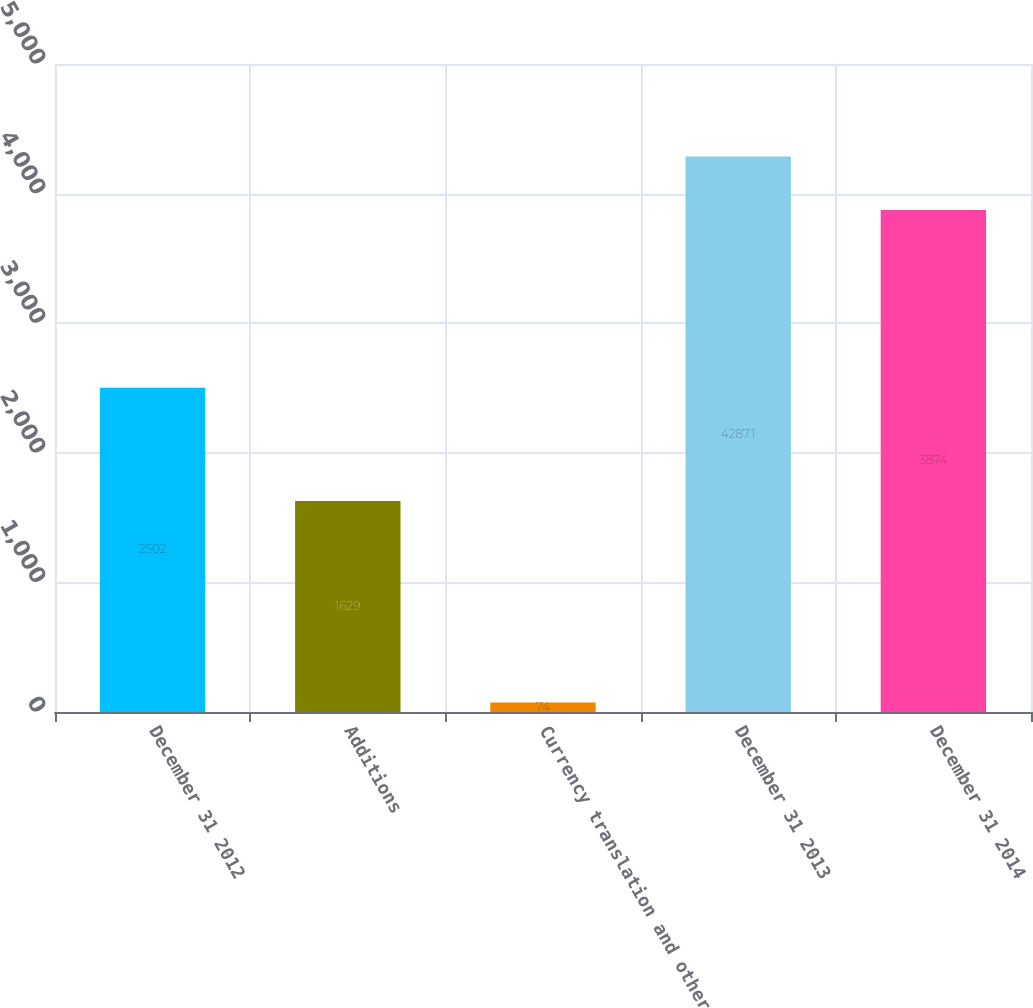Convert chart to OTSL. <chart><loc_0><loc_0><loc_500><loc_500><bar_chart><fcel>December 31 2012<fcel>Additions<fcel>Currency translation and other<fcel>December 31 2013<fcel>December 31 2014<nl><fcel>2502<fcel>1629<fcel>74<fcel>4287.1<fcel>3874<nl></chart> 